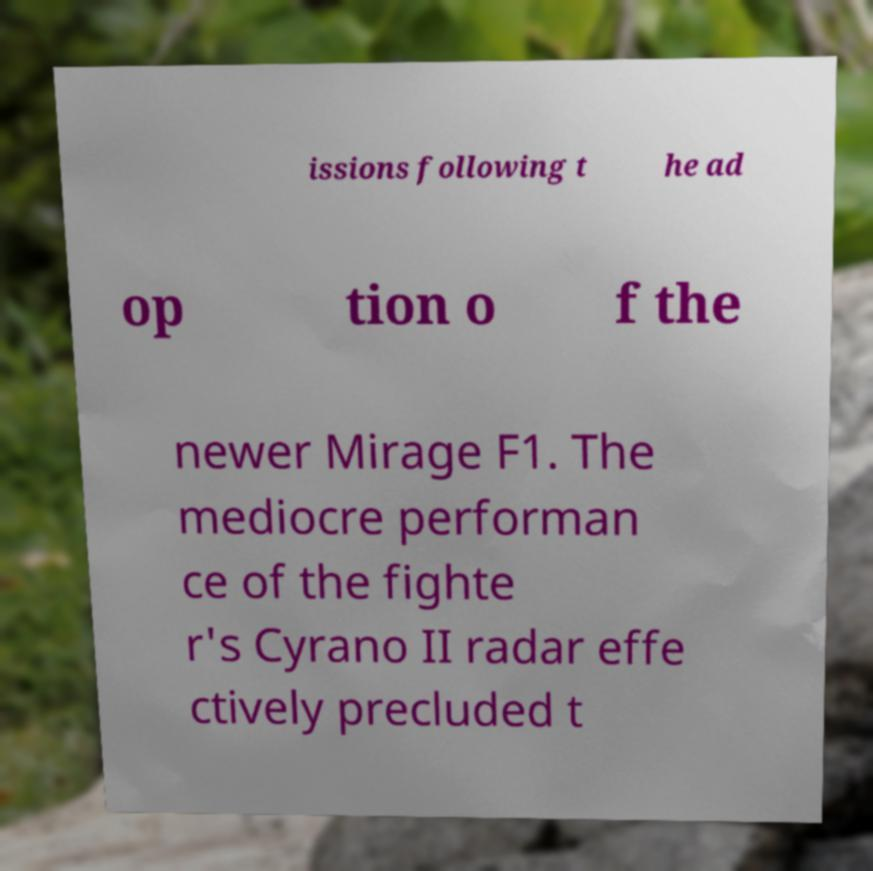Can you accurately transcribe the text from the provided image for me? issions following t he ad op tion o f the newer Mirage F1. The mediocre performan ce of the fighte r's Cyrano II radar effe ctively precluded t 